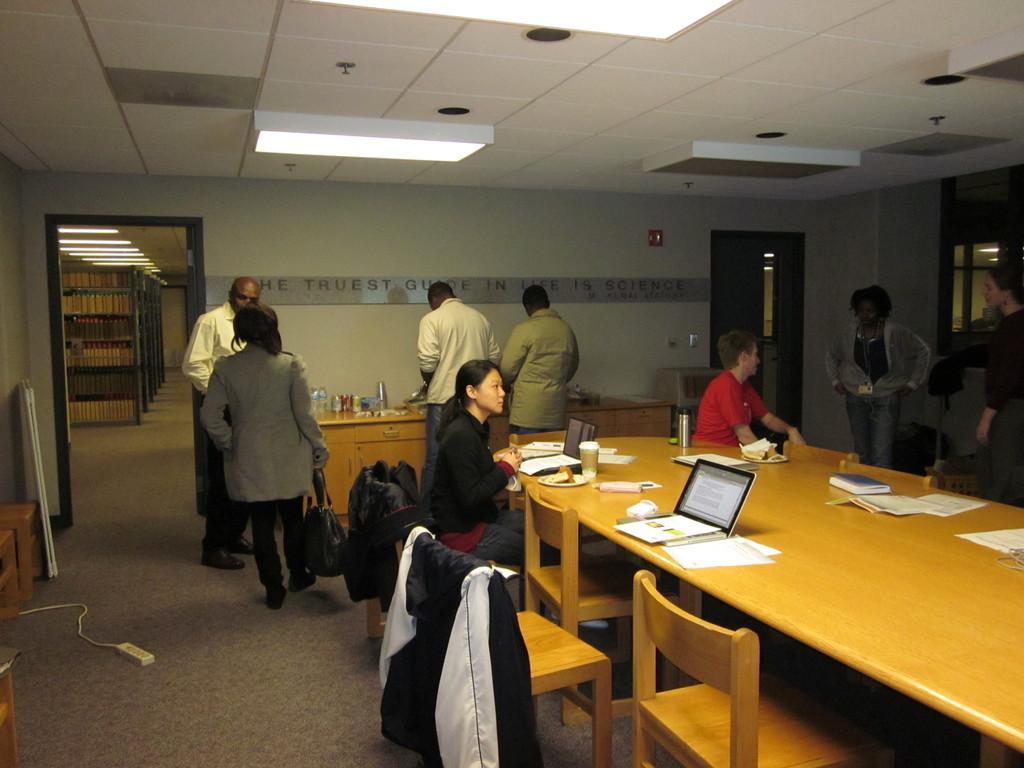In one or two sentences, can you explain what this image depicts? In this picture we can see some people are sitting and some people are in standing position they are talking with each other there and so many chairs in front of the table on the table we have books, papers, laptops, bottles, cups at back side we can see one more table on that table we have some eatable things bottles cup and we have a door. At the background we can see shelf's which is filled with full of books. 